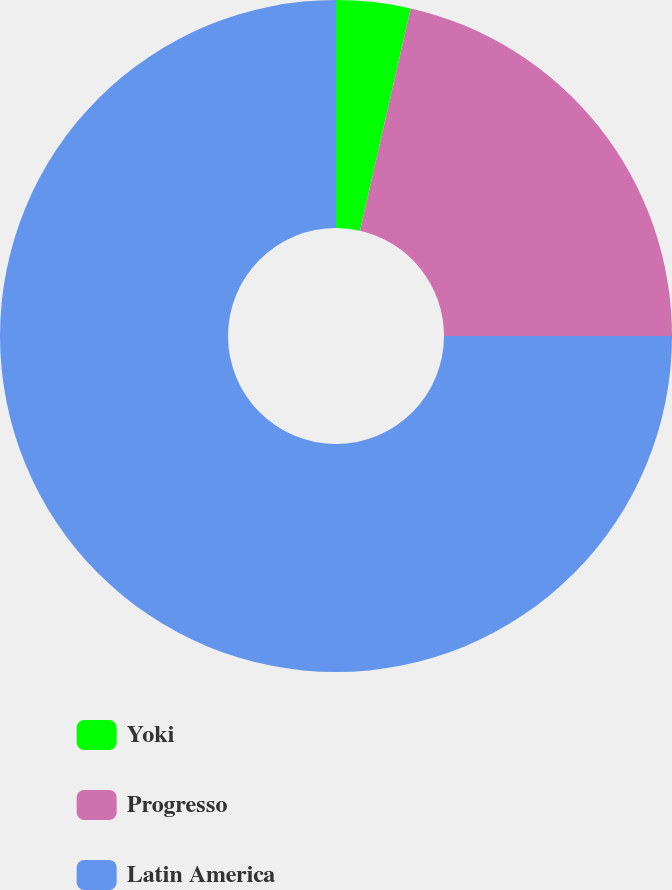Convert chart. <chart><loc_0><loc_0><loc_500><loc_500><pie_chart><fcel>Yoki<fcel>Progresso<fcel>Latin America<nl><fcel>3.57%<fcel>21.43%<fcel>75.0%<nl></chart> 